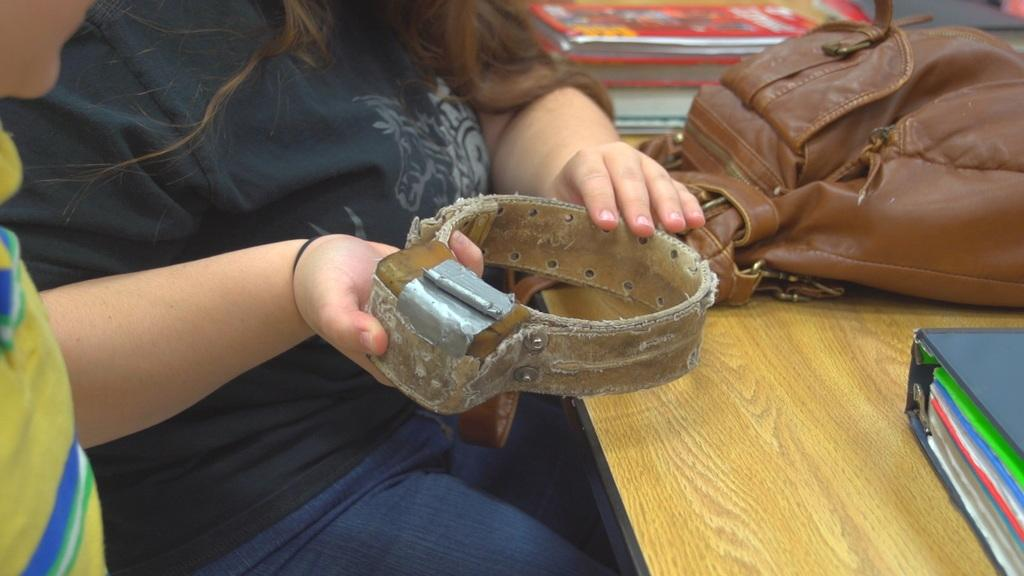How many people are in the image? There are two persons in the image. What is one of the persons doing in the image? One person is holding an object. What can be seen in the image besides the people? There is a bag and books on a table in the image. Where is the sink located in the image? There is no sink present in the image. What type of scarf is the person wearing in the image? There is no scarf visible in the image. 